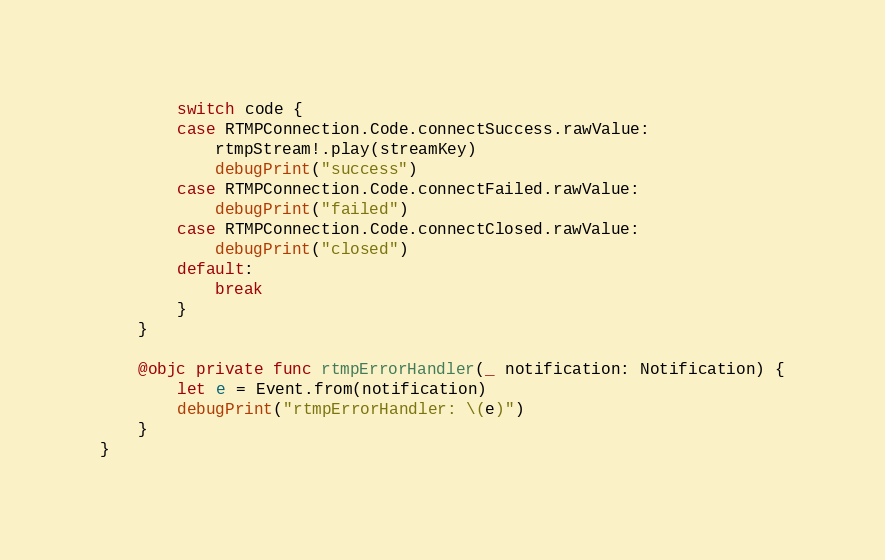<code> <loc_0><loc_0><loc_500><loc_500><_Swift_>        switch code {
        case RTMPConnection.Code.connectSuccess.rawValue:
            rtmpStream!.play(streamKey)
            debugPrint("success")
        case RTMPConnection.Code.connectFailed.rawValue:
            debugPrint("failed")
        case RTMPConnection.Code.connectClosed.rawValue:
            debugPrint("closed")
        default:
            break
        }
    }
    
    @objc private func rtmpErrorHandler(_ notification: Notification) {
        let e = Event.from(notification)
        debugPrint("rtmpErrorHandler: \(e)")
    }
}

</code> 